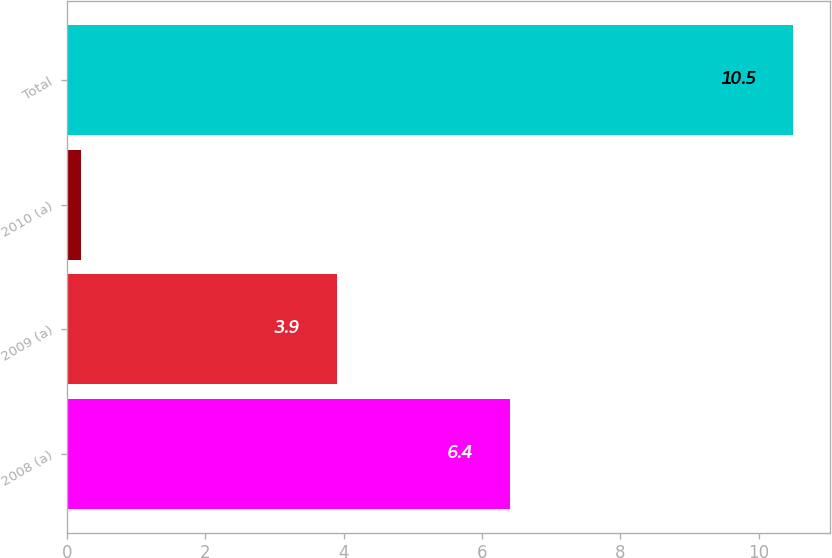<chart> <loc_0><loc_0><loc_500><loc_500><bar_chart><fcel>2008 (a)<fcel>2009 (a)<fcel>2010 (a)<fcel>Total<nl><fcel>6.4<fcel>3.9<fcel>0.2<fcel>10.5<nl></chart> 